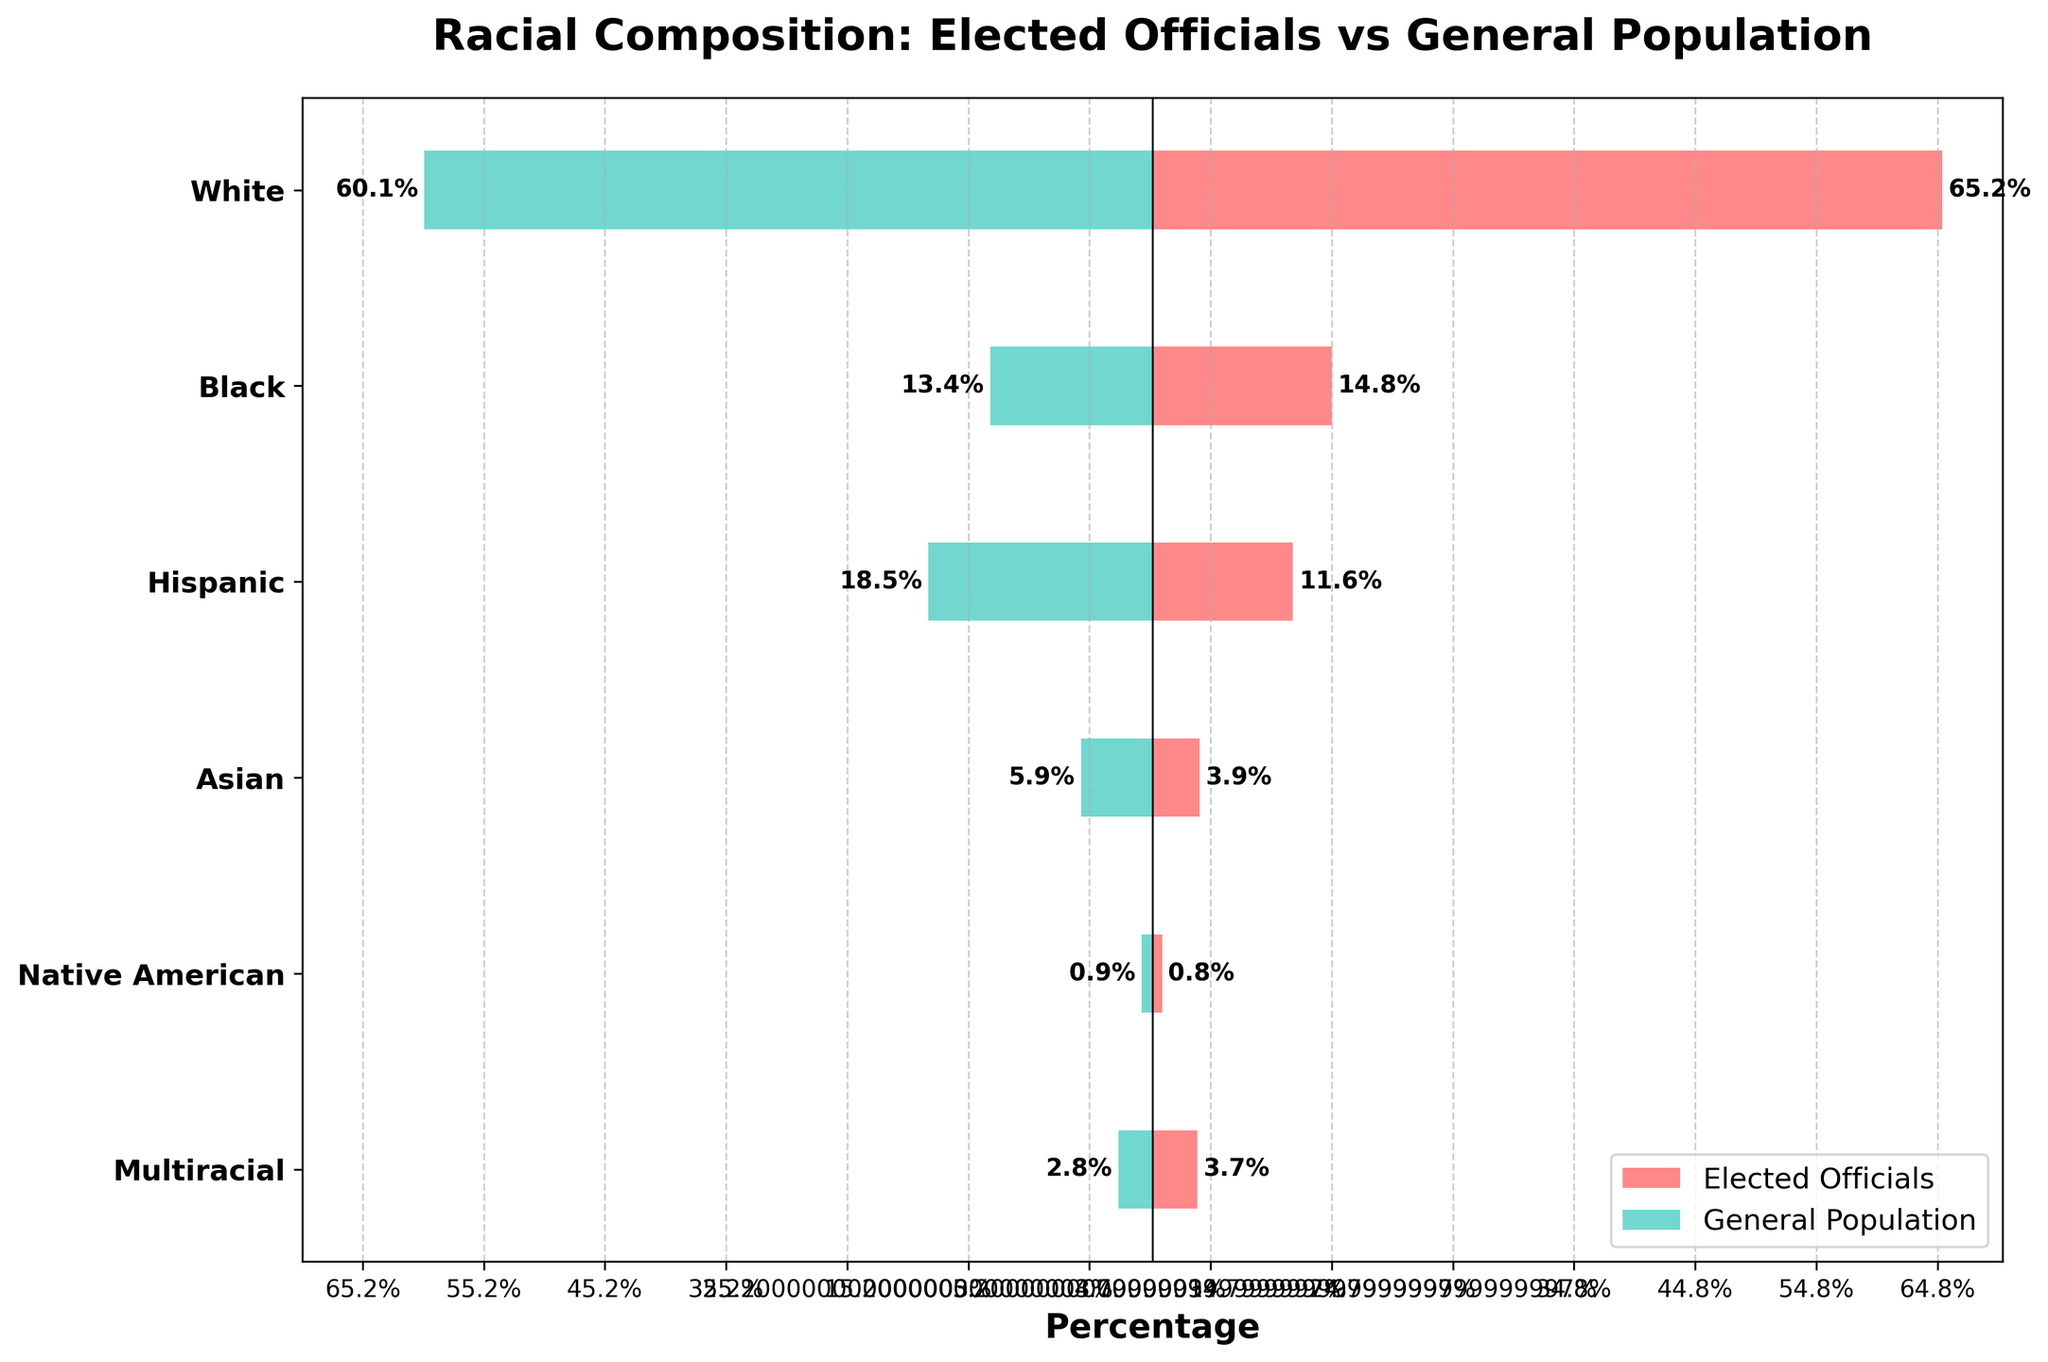What is the title of the figure? The title is prominently displayed at the top of the figure. It reads, "Racial Composition: Elected Officials vs General Population".
Answer: Racial Composition: Elected Officials vs General Population What colors represent elected officials and the general population in the bars? The bars representing elected officials are in red, and those representing the general population are in teal.
Answer: Elected Officials: red, General Population: teal Which racial category has the largest difference between elected officials and the general population? By observing the lengths of the bars, the Hispanic category shows a significant difference. The elected officials' percentage is 11.6%, while the general population's percentage is 18.5%.
Answer: Hispanic How many racial categories are there in the figure? The y-axis lists the racial categories. There are six categories depicted.
Answer: Six For the Black racial category, is the percentage of elected officials greater than, less than, or equal to the percentage of the general population? The split bars for the Black category show that the percentage for elected officials (14.8%) is greater than for the general population (13.4%).
Answer: Greater than What is the combined percentage of White and Black elected officials? The combined percentage of White and Black elected officials is found by adding their percentages: 65.2% (White) + 14.8% (Black) = 80%.
Answer: 80% Which racial category has the smallest representation among elected officials? The Native American category has the smallest representation with an elected officials' percentage of 0.8%.
Answer: Native American What is the difference in percentage points between the general population and elected officials for the Asian category? The percentage of Asians in the general population is 5.9%, while it is 3.9% among elected officials. The difference is calculated as 5.9% - 3.9% = 2%.
Answer: 2% Is the percentage of elected officials for Native Americans closer to their general population percentage compared to Asians? For Native Americans, the elected officials' percentage is 0.8% and the general population percentage is 0.9%, giving a difference of 0.1%. For Asians, the elected officials' percentage is 3.9% and the general population percentage is 5.9%, giving a difference of 2%. 0.1% is indeed closer than 2%.
Answer: Yes Which two racial categories have nearly equal representation in the general population? The general population percentages for Native Americans (0.9%) and Multiracial individuals (2.8%) indicate that these two categories have close values.
Answer: Native American and Multiracial 